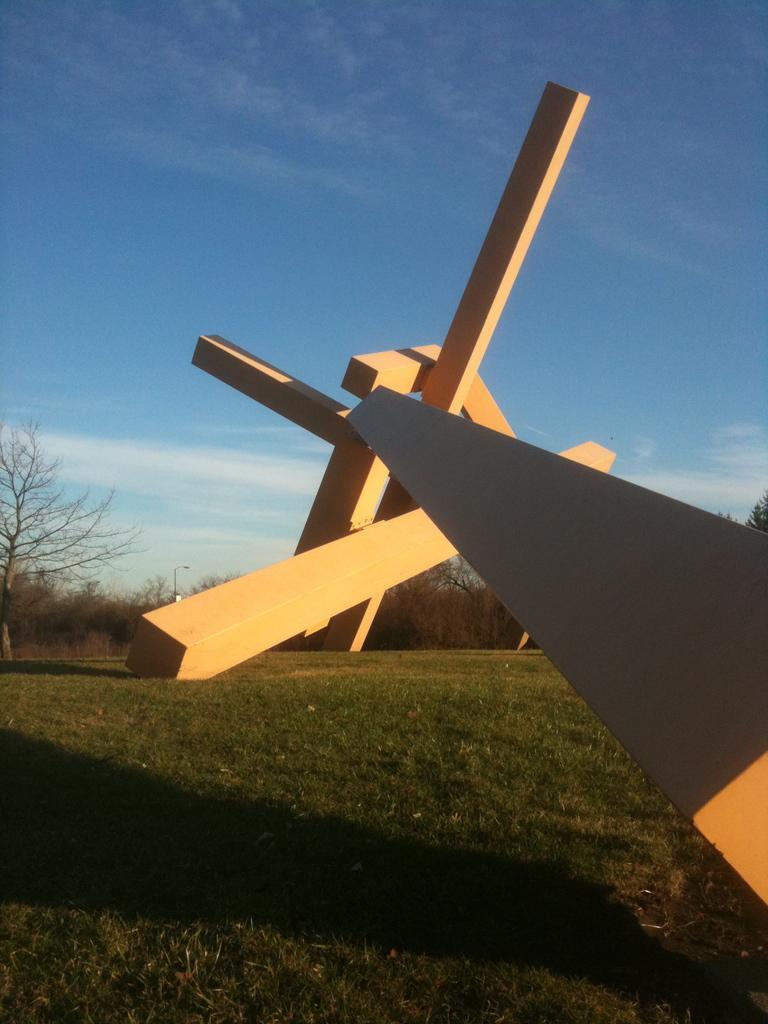Can you describe this image briefly? As we can see in the image there is grass, trees and sky. 